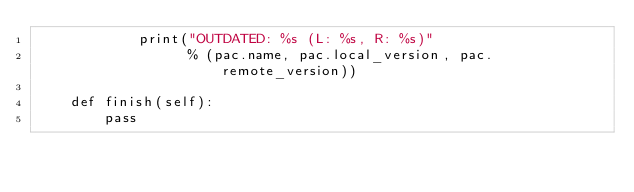<code> <loc_0><loc_0><loc_500><loc_500><_Python_>            print("OUTDATED: %s (L: %s, R: %s)"
                  % (pac.name, pac.local_version, pac.remote_version))

    def finish(self):
        pass
</code> 